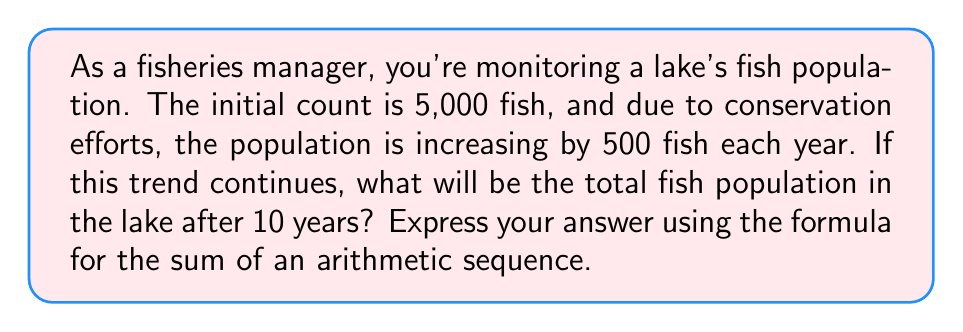Could you help me with this problem? To solve this problem, we'll use the formula for the sum of an arithmetic sequence:

$$S_n = \frac{n}{2}(a_1 + a_n)$$

Where:
$S_n$ is the sum of the sequence (total fish population after 10 years)
$n$ is the number of terms (11, as we count the initial year plus 10 more)
$a_1$ is the first term (initial population: 5,000)
$a_n$ is the last term (population after 10 years)

First, we need to calculate $a_n$:
$a_n = a_1 + (n-1)d$
Where $d$ is the common difference (500 fish per year)

$a_n = 5,000 + (10)(500) = 10,000$

Now we can plug these values into the sum formula:

$$S_{11} = \frac{11}{2}(5,000 + 10,000)$$
$$S_{11} = \frac{11}{2}(15,000)$$
$$S_{11} = 11(7,500)$$
$$S_{11} = 82,500$$
Answer: The total fish population in the lake after 10 years will be 82,500 fish. 